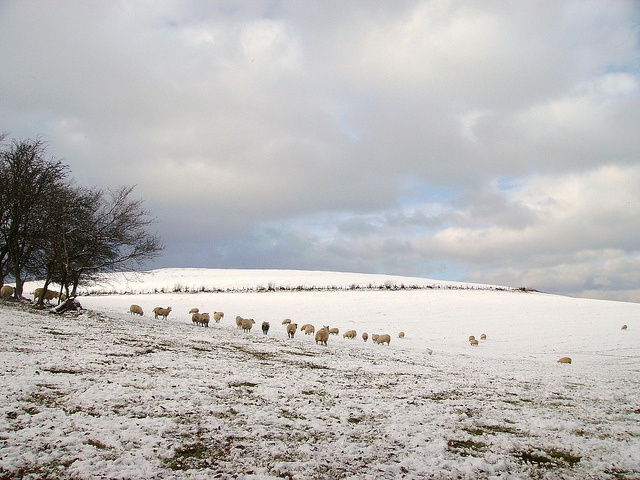Describe the objects in this image and their specific colors. I can see sheep in darkgray, lightgray, black, gray, and tan tones, sheep in darkgray, gray, tan, and brown tones, sheep in darkgray and gray tones, sheep in darkgray, gray, lightgray, and black tones, and sheep in darkgray, gray, and tan tones in this image. 